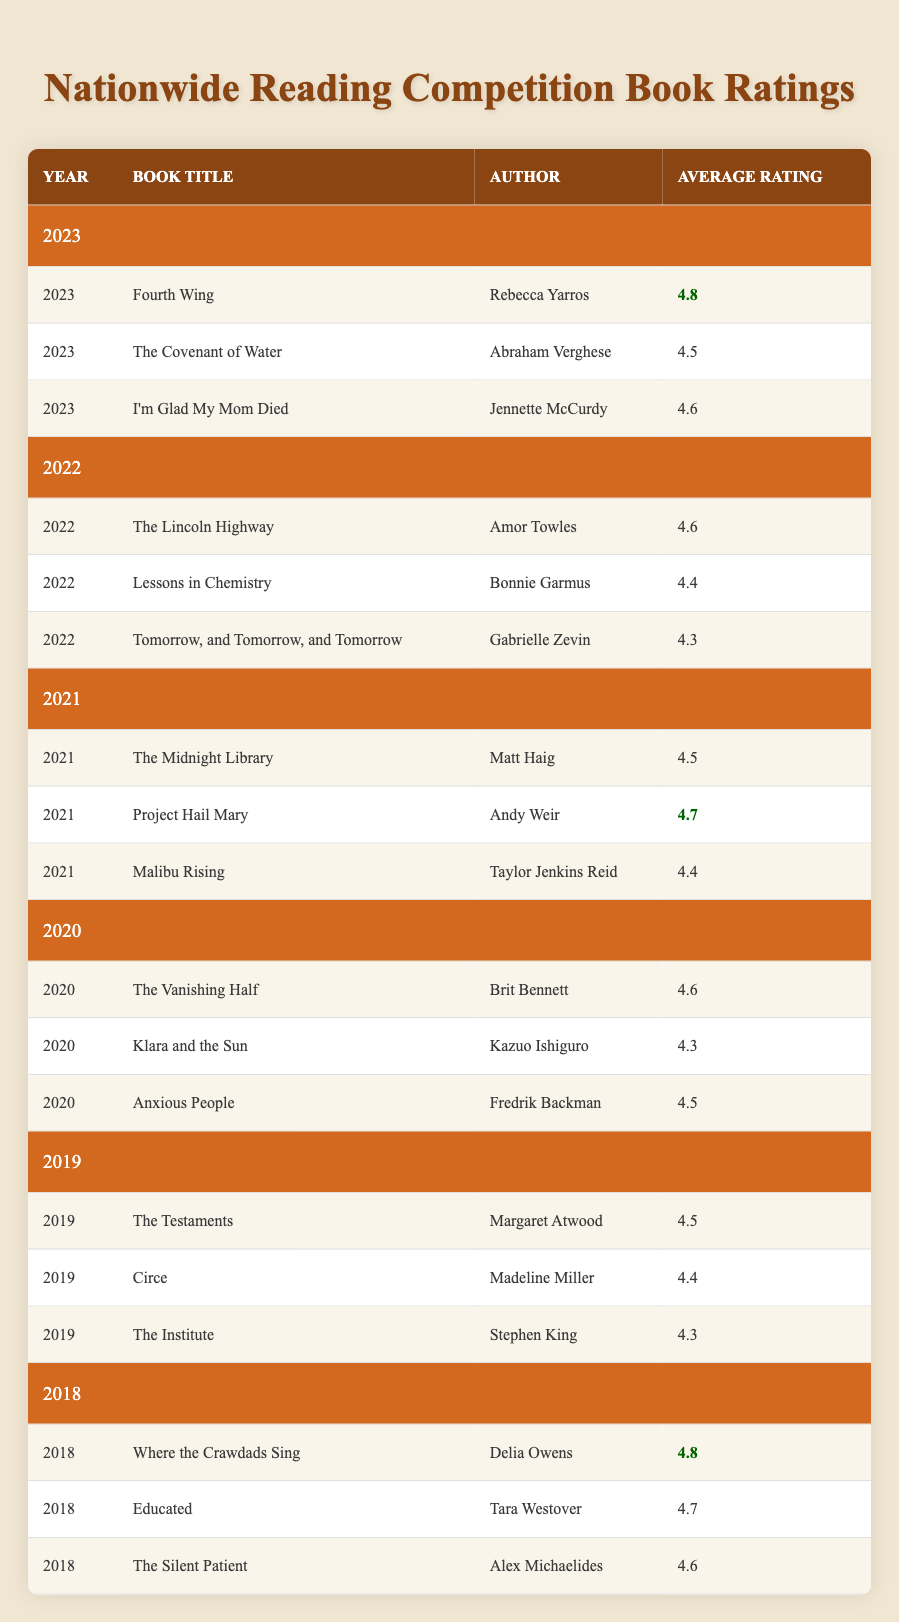What is the highest-rated book in 2023? The highest-rated book in 2023 is "Fourth Wing" by Rebecca Yarros, which has an average rating of 4.8. This is noted clearly in the table under the 2023 category.
Answer: Fourth Wing Which book had the lowest average rating in 2019? In 2019, "The Institute" by Stephen King had the lowest average rating of 4.3 among the listed books for that year. This can be found by comparing the average ratings for all books listed in 2019.
Answer: The Institute How does the average rating of "The Lincoln Highway" compare to "Circe"? "The Lincoln Highway" has an average rating of 4.6, while "Circe" has an average rating of 4.4. Thus, "The Lincoln Highway" is rated higher than "Circe" by 0.2. This requires comparing the two specific average ratings in the table.
Answer: 0.2 What is the average rating of the three books listed in 2020? To find the average rating for the books listed in 2020, add their average ratings: 4.6 (The Vanishing Half) + 4.3 (Klara and the Sun) + 4.5 (Anxious People) = 13.4. Then, divide by 3 (the number of books): 13.4 / 3 = 4.47, which can be rounded for clarity.
Answer: 4.47 Was "The Silent Patient" rated higher than "Educated"? "The Silent Patient" has an average rating of 4.6, while "Educated" has a rating of 4.7. Since 4.6 is less than 4.7, "The Silent Patient" was not rated higher than "Educated". This is a straightforward comparison of their ratings.
Answer: No Which author wrote two books that had an average rating of 4.5 or higher in consecutive years? In 2021, Andy Weir's book "Project Hail Mary" had an average rating of 4.7, and in 2020, Fredrik Backman's "Anxious People" had a rating of 4.5. Both ratings are 4.5 or higher and are listed in consecutive years, indicating the author's recent acclaim.
Answer: Andy Weir What is the difference between the highest and lowest average ratings in 2022? The highest-rated book in 2022 is "The Lincoln Highway" with an average rating of 4.6, and the lowest is "Tomorrow, and Tomorrow, and Tomorrow" with 4.3. To find the difference, subtract the two: 4.6 - 4.3 = 0.3. This calculation signifies the gap in ratings within the year.
Answer: 0.3 How many books had an average rating of 4.4 in 2021 and 2022 combined? In 2021, "Malibu Rising" had a rating of 4.4, and in 2022, "Lessons in Chemistry" also had a rating of 4.4. Therefore, there are two books with an average rating of 4.4 when considering both years.
Answer: 2 Which book in 2018 had an average rating equal to the highest in 2023? In 2018, "Where the Crawdads Sing" had an average rating of 4.8, which is equal to the rating of "Fourth Wing" in 2023, also rated 4.8. This requires identifying the book with the 4.8 rating in both years.
Answer: Where the Crawdads Sing 